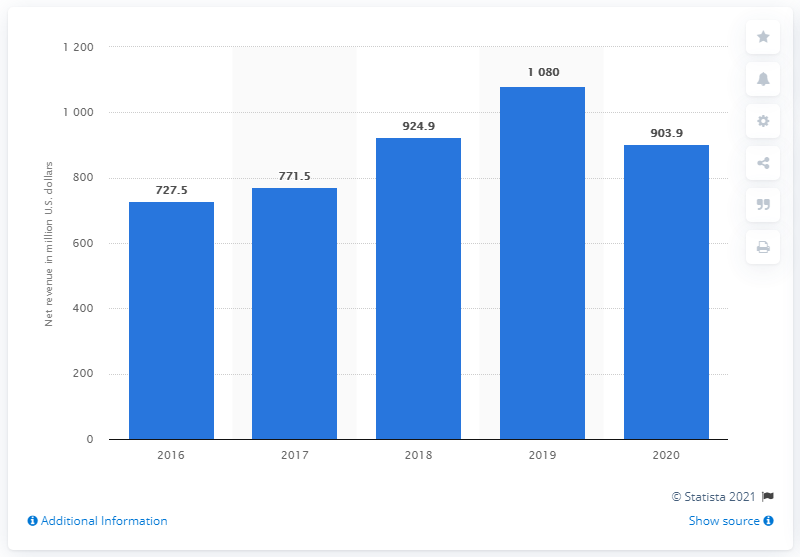Give some essential details in this illustration. Cree's revenue in the fiscal year of 2020 was 903.9 million dollars. 